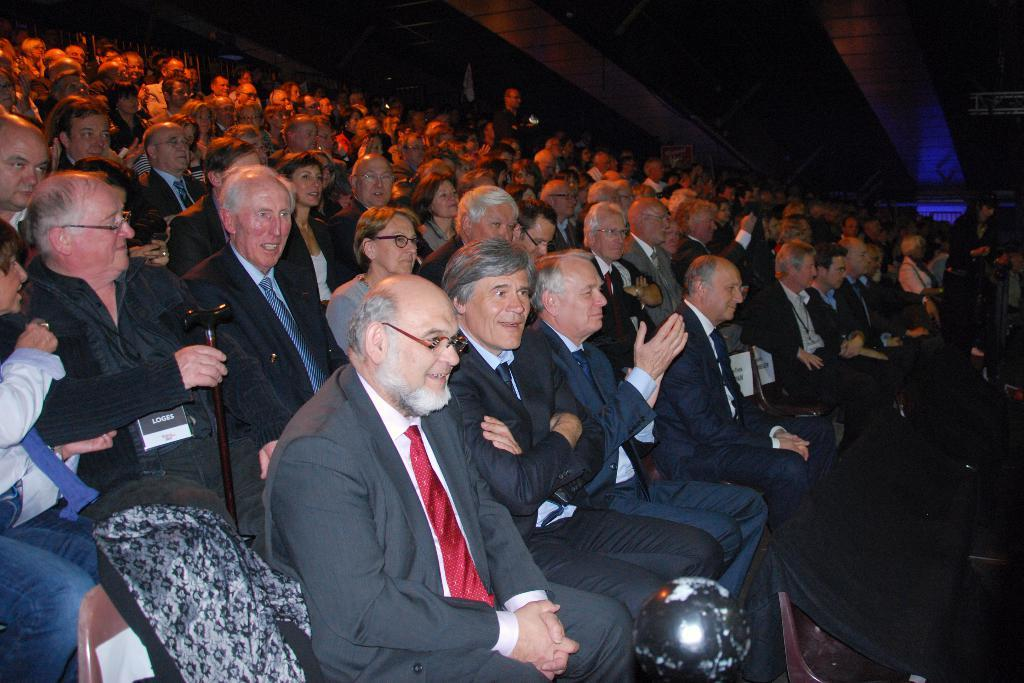What is the arrangement of the chairs in the image? There are multiple chairs arranged in lines in the image. What are the people in the chairs doing? People are sitting in the chairs, and the people in the front row are clapping. Can you describe the setting where the chairs are located? The setting appears to be a hall. Where is the dad sitting in the image? There is no dad mentioned or visible in the image. How many rabbits can be seen in the image? There are no rabbits present in the image. 